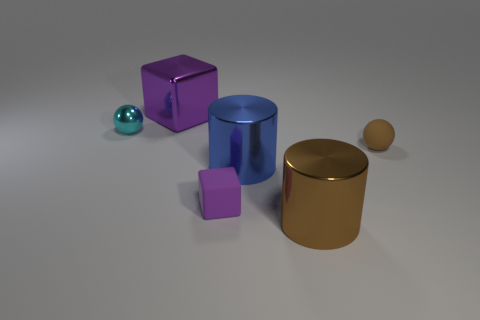Are there the same number of tiny brown balls that are behind the purple metal block and matte objects that are to the right of the small cube?
Make the answer very short. No. There is a ball that is right of the metallic object that is behind the cyan object; what number of metallic things are in front of it?
Give a very brief answer. 2. There is a object that is the same color as the tiny matte ball; what shape is it?
Your answer should be compact. Cylinder. Does the tiny rubber block have the same color as the small object left of the purple metal block?
Your response must be concise. No. Are there more small shiny objects that are behind the large blue metallic cylinder than blue objects?
Your answer should be very brief. No. How many objects are either metal objects behind the small brown rubber ball or metallic things right of the big blue object?
Your answer should be very brief. 3. The blue cylinder that is made of the same material as the cyan ball is what size?
Provide a succinct answer. Large. There is a large thing that is behind the tiny cyan sphere; is its shape the same as the cyan metallic thing?
Provide a succinct answer. No. There is a matte thing that is the same color as the big block; what is its size?
Your response must be concise. Small. How many blue things are shiny objects or cubes?
Give a very brief answer. 1. 